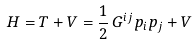Convert formula to latex. <formula><loc_0><loc_0><loc_500><loc_500>H = T + V = \frac { 1 } { 2 } \, G ^ { i j } p _ { i } p _ { j } + V</formula> 